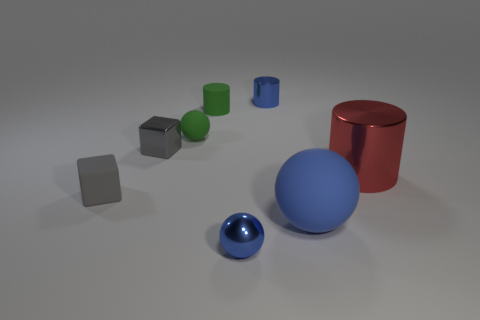What sizes are the objects in the image, relative to each other? The objects in the image display a variety of sizes. The red cylinder and the large blue sphere are the most prominent, whereas the gray cubes and the small blue sphere are much smaller in comparison. How do the textures of these objects contrast? The textures provide a noticeable contrast - the spheres and the cylinders have a reflective, smooth texture, indicating possibly a metallic or polished surface, while the cubes appear to have a matte finish, suggestive of a more diffuse or softer material. 